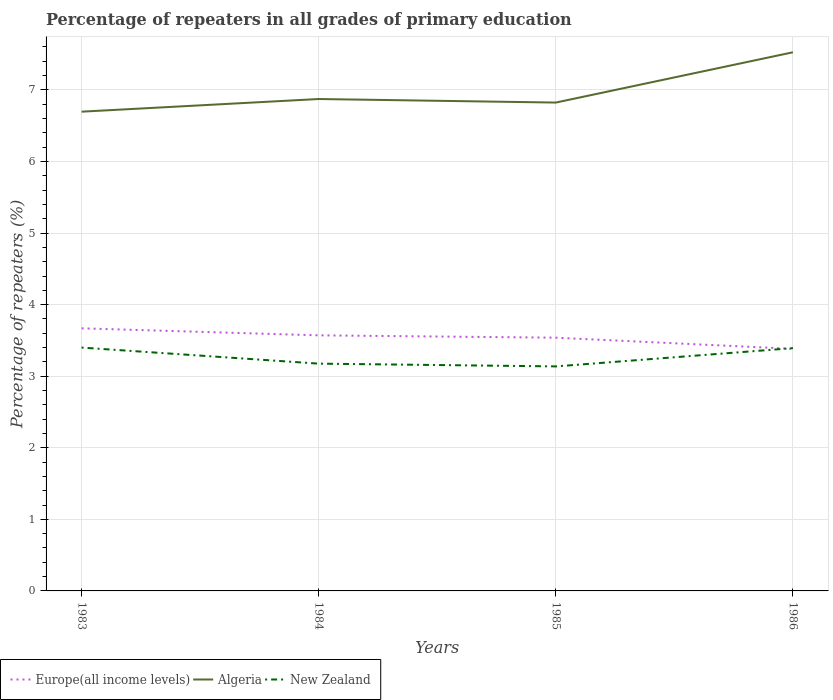How many different coloured lines are there?
Offer a terse response. 3. Does the line corresponding to New Zealand intersect with the line corresponding to Europe(all income levels)?
Offer a terse response. Yes. Is the number of lines equal to the number of legend labels?
Offer a very short reply. Yes. Across all years, what is the maximum percentage of repeaters in Algeria?
Your answer should be compact. 6.7. In which year was the percentage of repeaters in New Zealand maximum?
Make the answer very short. 1985. What is the total percentage of repeaters in New Zealand in the graph?
Provide a succinct answer. 0.26. What is the difference between the highest and the second highest percentage of repeaters in New Zealand?
Your answer should be very brief. 0.26. Is the percentage of repeaters in New Zealand strictly greater than the percentage of repeaters in Europe(all income levels) over the years?
Provide a succinct answer. No. How many years are there in the graph?
Your answer should be compact. 4. What is the difference between two consecutive major ticks on the Y-axis?
Ensure brevity in your answer.  1. Where does the legend appear in the graph?
Provide a succinct answer. Bottom left. How many legend labels are there?
Keep it short and to the point. 3. What is the title of the graph?
Offer a very short reply. Percentage of repeaters in all grades of primary education. What is the label or title of the Y-axis?
Make the answer very short. Percentage of repeaters (%). What is the Percentage of repeaters (%) in Europe(all income levels) in 1983?
Give a very brief answer. 3.67. What is the Percentage of repeaters (%) in Algeria in 1983?
Your answer should be compact. 6.7. What is the Percentage of repeaters (%) of New Zealand in 1983?
Your response must be concise. 3.4. What is the Percentage of repeaters (%) in Europe(all income levels) in 1984?
Provide a short and direct response. 3.57. What is the Percentage of repeaters (%) in Algeria in 1984?
Offer a terse response. 6.87. What is the Percentage of repeaters (%) of New Zealand in 1984?
Give a very brief answer. 3.18. What is the Percentage of repeaters (%) in Europe(all income levels) in 1985?
Your response must be concise. 3.54. What is the Percentage of repeaters (%) in Algeria in 1985?
Provide a succinct answer. 6.82. What is the Percentage of repeaters (%) in New Zealand in 1985?
Offer a terse response. 3.14. What is the Percentage of repeaters (%) of Europe(all income levels) in 1986?
Your response must be concise. 3.38. What is the Percentage of repeaters (%) in Algeria in 1986?
Ensure brevity in your answer.  7.53. What is the Percentage of repeaters (%) of New Zealand in 1986?
Your response must be concise. 3.39. Across all years, what is the maximum Percentage of repeaters (%) in Europe(all income levels)?
Provide a short and direct response. 3.67. Across all years, what is the maximum Percentage of repeaters (%) of Algeria?
Provide a short and direct response. 7.53. Across all years, what is the maximum Percentage of repeaters (%) of New Zealand?
Your answer should be compact. 3.4. Across all years, what is the minimum Percentage of repeaters (%) of Europe(all income levels)?
Ensure brevity in your answer.  3.38. Across all years, what is the minimum Percentage of repeaters (%) in Algeria?
Give a very brief answer. 6.7. Across all years, what is the minimum Percentage of repeaters (%) in New Zealand?
Make the answer very short. 3.14. What is the total Percentage of repeaters (%) in Europe(all income levels) in the graph?
Make the answer very short. 14.16. What is the total Percentage of repeaters (%) of Algeria in the graph?
Offer a terse response. 27.92. What is the total Percentage of repeaters (%) in New Zealand in the graph?
Give a very brief answer. 13.1. What is the difference between the Percentage of repeaters (%) in Europe(all income levels) in 1983 and that in 1984?
Offer a terse response. 0.1. What is the difference between the Percentage of repeaters (%) of Algeria in 1983 and that in 1984?
Your response must be concise. -0.18. What is the difference between the Percentage of repeaters (%) in New Zealand in 1983 and that in 1984?
Provide a succinct answer. 0.22. What is the difference between the Percentage of repeaters (%) in Europe(all income levels) in 1983 and that in 1985?
Ensure brevity in your answer.  0.13. What is the difference between the Percentage of repeaters (%) in Algeria in 1983 and that in 1985?
Keep it short and to the point. -0.13. What is the difference between the Percentage of repeaters (%) in New Zealand in 1983 and that in 1985?
Keep it short and to the point. 0.26. What is the difference between the Percentage of repeaters (%) of Europe(all income levels) in 1983 and that in 1986?
Your answer should be compact. 0.29. What is the difference between the Percentage of repeaters (%) of Algeria in 1983 and that in 1986?
Keep it short and to the point. -0.83. What is the difference between the Percentage of repeaters (%) in New Zealand in 1983 and that in 1986?
Ensure brevity in your answer.  0.01. What is the difference between the Percentage of repeaters (%) of Europe(all income levels) in 1984 and that in 1985?
Make the answer very short. 0.03. What is the difference between the Percentage of repeaters (%) in Algeria in 1984 and that in 1985?
Give a very brief answer. 0.05. What is the difference between the Percentage of repeaters (%) in New Zealand in 1984 and that in 1985?
Offer a terse response. 0.04. What is the difference between the Percentage of repeaters (%) in Europe(all income levels) in 1984 and that in 1986?
Your answer should be compact. 0.19. What is the difference between the Percentage of repeaters (%) of Algeria in 1984 and that in 1986?
Offer a very short reply. -0.65. What is the difference between the Percentage of repeaters (%) in New Zealand in 1984 and that in 1986?
Keep it short and to the point. -0.22. What is the difference between the Percentage of repeaters (%) in Europe(all income levels) in 1985 and that in 1986?
Offer a terse response. 0.16. What is the difference between the Percentage of repeaters (%) in Algeria in 1985 and that in 1986?
Provide a succinct answer. -0.7. What is the difference between the Percentage of repeaters (%) in New Zealand in 1985 and that in 1986?
Your response must be concise. -0.26. What is the difference between the Percentage of repeaters (%) in Europe(all income levels) in 1983 and the Percentage of repeaters (%) in Algeria in 1984?
Make the answer very short. -3.2. What is the difference between the Percentage of repeaters (%) in Europe(all income levels) in 1983 and the Percentage of repeaters (%) in New Zealand in 1984?
Your answer should be very brief. 0.49. What is the difference between the Percentage of repeaters (%) of Algeria in 1983 and the Percentage of repeaters (%) of New Zealand in 1984?
Your answer should be very brief. 3.52. What is the difference between the Percentage of repeaters (%) of Europe(all income levels) in 1983 and the Percentage of repeaters (%) of Algeria in 1985?
Your answer should be compact. -3.15. What is the difference between the Percentage of repeaters (%) of Europe(all income levels) in 1983 and the Percentage of repeaters (%) of New Zealand in 1985?
Your answer should be very brief. 0.53. What is the difference between the Percentage of repeaters (%) in Algeria in 1983 and the Percentage of repeaters (%) in New Zealand in 1985?
Offer a very short reply. 3.56. What is the difference between the Percentage of repeaters (%) in Europe(all income levels) in 1983 and the Percentage of repeaters (%) in Algeria in 1986?
Offer a very short reply. -3.86. What is the difference between the Percentage of repeaters (%) of Europe(all income levels) in 1983 and the Percentage of repeaters (%) of New Zealand in 1986?
Offer a terse response. 0.28. What is the difference between the Percentage of repeaters (%) of Algeria in 1983 and the Percentage of repeaters (%) of New Zealand in 1986?
Keep it short and to the point. 3.3. What is the difference between the Percentage of repeaters (%) of Europe(all income levels) in 1984 and the Percentage of repeaters (%) of Algeria in 1985?
Offer a terse response. -3.25. What is the difference between the Percentage of repeaters (%) of Europe(all income levels) in 1984 and the Percentage of repeaters (%) of New Zealand in 1985?
Provide a short and direct response. 0.43. What is the difference between the Percentage of repeaters (%) in Algeria in 1984 and the Percentage of repeaters (%) in New Zealand in 1985?
Give a very brief answer. 3.74. What is the difference between the Percentage of repeaters (%) of Europe(all income levels) in 1984 and the Percentage of repeaters (%) of Algeria in 1986?
Provide a short and direct response. -3.95. What is the difference between the Percentage of repeaters (%) in Europe(all income levels) in 1984 and the Percentage of repeaters (%) in New Zealand in 1986?
Make the answer very short. 0.18. What is the difference between the Percentage of repeaters (%) in Algeria in 1984 and the Percentage of repeaters (%) in New Zealand in 1986?
Provide a short and direct response. 3.48. What is the difference between the Percentage of repeaters (%) of Europe(all income levels) in 1985 and the Percentage of repeaters (%) of Algeria in 1986?
Keep it short and to the point. -3.99. What is the difference between the Percentage of repeaters (%) in Europe(all income levels) in 1985 and the Percentage of repeaters (%) in New Zealand in 1986?
Your answer should be compact. 0.15. What is the difference between the Percentage of repeaters (%) of Algeria in 1985 and the Percentage of repeaters (%) of New Zealand in 1986?
Your answer should be very brief. 3.43. What is the average Percentage of repeaters (%) in Europe(all income levels) per year?
Give a very brief answer. 3.54. What is the average Percentage of repeaters (%) in Algeria per year?
Provide a short and direct response. 6.98. What is the average Percentage of repeaters (%) in New Zealand per year?
Provide a short and direct response. 3.28. In the year 1983, what is the difference between the Percentage of repeaters (%) of Europe(all income levels) and Percentage of repeaters (%) of Algeria?
Make the answer very short. -3.03. In the year 1983, what is the difference between the Percentage of repeaters (%) in Europe(all income levels) and Percentage of repeaters (%) in New Zealand?
Keep it short and to the point. 0.27. In the year 1983, what is the difference between the Percentage of repeaters (%) in Algeria and Percentage of repeaters (%) in New Zealand?
Offer a very short reply. 3.3. In the year 1984, what is the difference between the Percentage of repeaters (%) in Europe(all income levels) and Percentage of repeaters (%) in Algeria?
Make the answer very short. -3.3. In the year 1984, what is the difference between the Percentage of repeaters (%) of Europe(all income levels) and Percentage of repeaters (%) of New Zealand?
Your response must be concise. 0.4. In the year 1984, what is the difference between the Percentage of repeaters (%) in Algeria and Percentage of repeaters (%) in New Zealand?
Provide a short and direct response. 3.7. In the year 1985, what is the difference between the Percentage of repeaters (%) of Europe(all income levels) and Percentage of repeaters (%) of Algeria?
Provide a short and direct response. -3.29. In the year 1985, what is the difference between the Percentage of repeaters (%) in Europe(all income levels) and Percentage of repeaters (%) in New Zealand?
Your answer should be compact. 0.4. In the year 1985, what is the difference between the Percentage of repeaters (%) of Algeria and Percentage of repeaters (%) of New Zealand?
Give a very brief answer. 3.69. In the year 1986, what is the difference between the Percentage of repeaters (%) of Europe(all income levels) and Percentage of repeaters (%) of Algeria?
Your response must be concise. -4.14. In the year 1986, what is the difference between the Percentage of repeaters (%) of Europe(all income levels) and Percentage of repeaters (%) of New Zealand?
Your answer should be very brief. -0.01. In the year 1986, what is the difference between the Percentage of repeaters (%) of Algeria and Percentage of repeaters (%) of New Zealand?
Your answer should be very brief. 4.13. What is the ratio of the Percentage of repeaters (%) of Europe(all income levels) in 1983 to that in 1984?
Make the answer very short. 1.03. What is the ratio of the Percentage of repeaters (%) of Algeria in 1983 to that in 1984?
Your answer should be compact. 0.97. What is the ratio of the Percentage of repeaters (%) of New Zealand in 1983 to that in 1984?
Give a very brief answer. 1.07. What is the ratio of the Percentage of repeaters (%) in Europe(all income levels) in 1983 to that in 1985?
Keep it short and to the point. 1.04. What is the ratio of the Percentage of repeaters (%) of Algeria in 1983 to that in 1985?
Make the answer very short. 0.98. What is the ratio of the Percentage of repeaters (%) of New Zealand in 1983 to that in 1985?
Offer a very short reply. 1.08. What is the ratio of the Percentage of repeaters (%) of Europe(all income levels) in 1983 to that in 1986?
Keep it short and to the point. 1.08. What is the ratio of the Percentage of repeaters (%) of Algeria in 1983 to that in 1986?
Your answer should be very brief. 0.89. What is the ratio of the Percentage of repeaters (%) of Europe(all income levels) in 1984 to that in 1985?
Provide a short and direct response. 1.01. What is the ratio of the Percentage of repeaters (%) of Algeria in 1984 to that in 1985?
Provide a short and direct response. 1.01. What is the ratio of the Percentage of repeaters (%) in New Zealand in 1984 to that in 1985?
Offer a very short reply. 1.01. What is the ratio of the Percentage of repeaters (%) in Europe(all income levels) in 1984 to that in 1986?
Provide a succinct answer. 1.06. What is the ratio of the Percentage of repeaters (%) in Algeria in 1984 to that in 1986?
Make the answer very short. 0.91. What is the ratio of the Percentage of repeaters (%) in New Zealand in 1984 to that in 1986?
Provide a short and direct response. 0.94. What is the ratio of the Percentage of repeaters (%) of Europe(all income levels) in 1985 to that in 1986?
Offer a very short reply. 1.05. What is the ratio of the Percentage of repeaters (%) of Algeria in 1985 to that in 1986?
Offer a very short reply. 0.91. What is the ratio of the Percentage of repeaters (%) in New Zealand in 1985 to that in 1986?
Offer a terse response. 0.92. What is the difference between the highest and the second highest Percentage of repeaters (%) of Europe(all income levels)?
Your response must be concise. 0.1. What is the difference between the highest and the second highest Percentage of repeaters (%) of Algeria?
Make the answer very short. 0.65. What is the difference between the highest and the second highest Percentage of repeaters (%) of New Zealand?
Offer a terse response. 0.01. What is the difference between the highest and the lowest Percentage of repeaters (%) in Europe(all income levels)?
Your answer should be compact. 0.29. What is the difference between the highest and the lowest Percentage of repeaters (%) of Algeria?
Your answer should be very brief. 0.83. What is the difference between the highest and the lowest Percentage of repeaters (%) of New Zealand?
Offer a terse response. 0.26. 